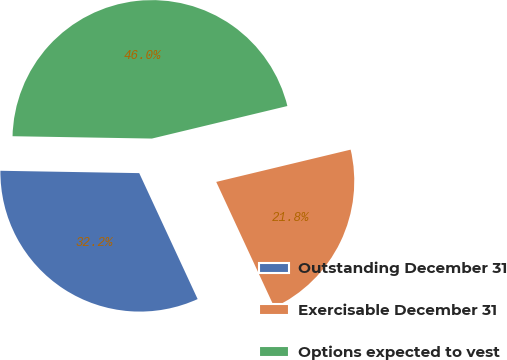<chart> <loc_0><loc_0><loc_500><loc_500><pie_chart><fcel>Outstanding December 31<fcel>Exercisable December 31<fcel>Options expected to vest<nl><fcel>32.18%<fcel>21.84%<fcel>45.98%<nl></chart> 